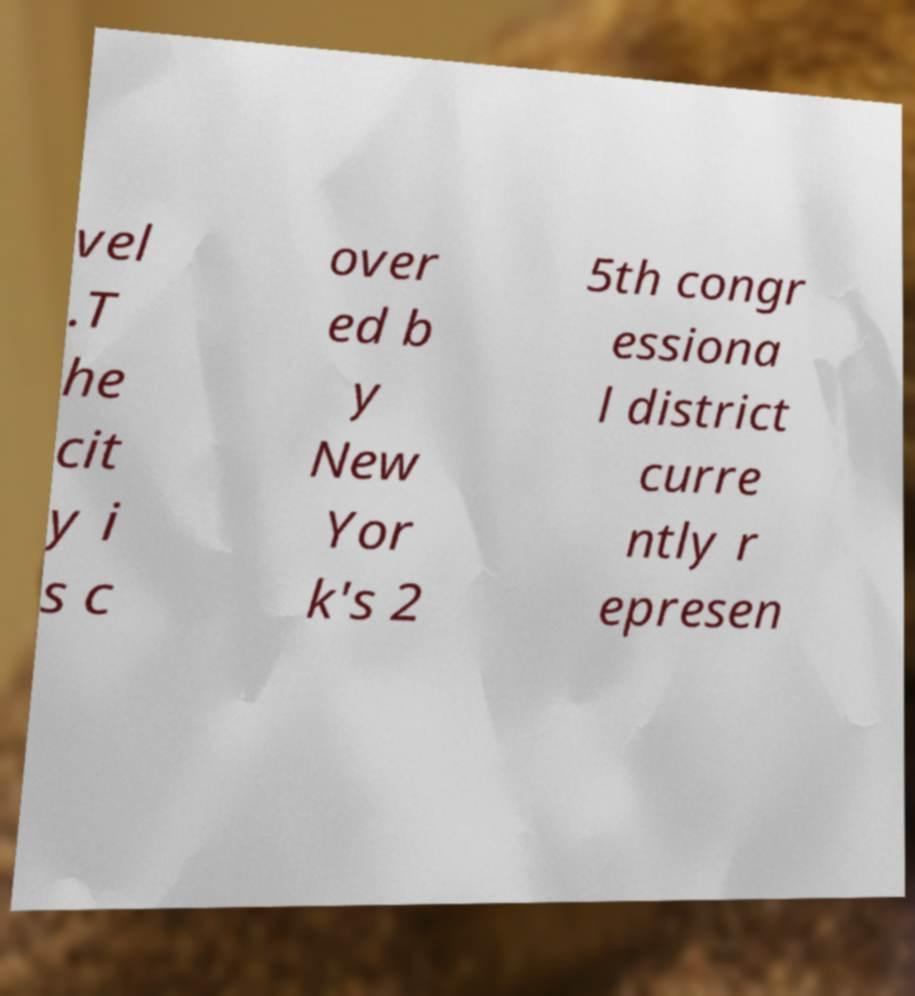Can you read and provide the text displayed in the image?This photo seems to have some interesting text. Can you extract and type it out for me? vel .T he cit y i s c over ed b y New Yor k's 2 5th congr essiona l district curre ntly r epresen 